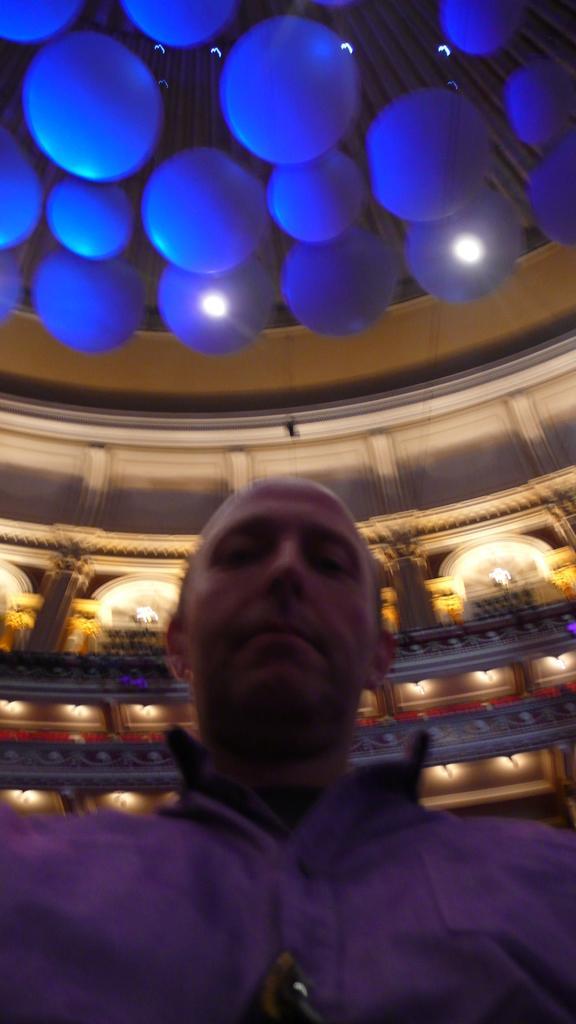Please provide a concise description of this image. In this image we can see a man. In the background there is a wall and we can see lights. At the top there are decors. 